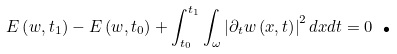<formula> <loc_0><loc_0><loc_500><loc_500>E \left ( w , t _ { 1 } \right ) - E \left ( w , t _ { 0 } \right ) + \int _ { t _ { 0 } } ^ { t _ { 1 } } \int _ { \omega } \left | \partial _ { t } w \left ( x , t \right ) \right | ^ { 2 } d x d t = 0 \text { .}</formula> 